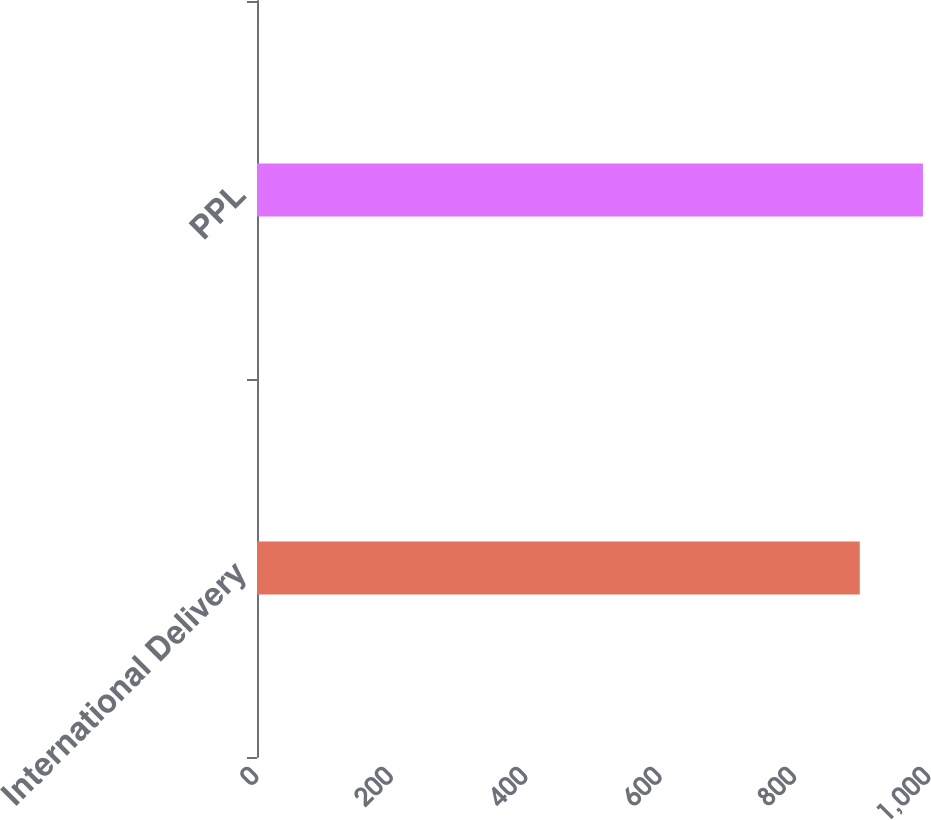Convert chart to OTSL. <chart><loc_0><loc_0><loc_500><loc_500><bar_chart><fcel>International Delivery<fcel>PPL<nl><fcel>897<fcel>991<nl></chart> 